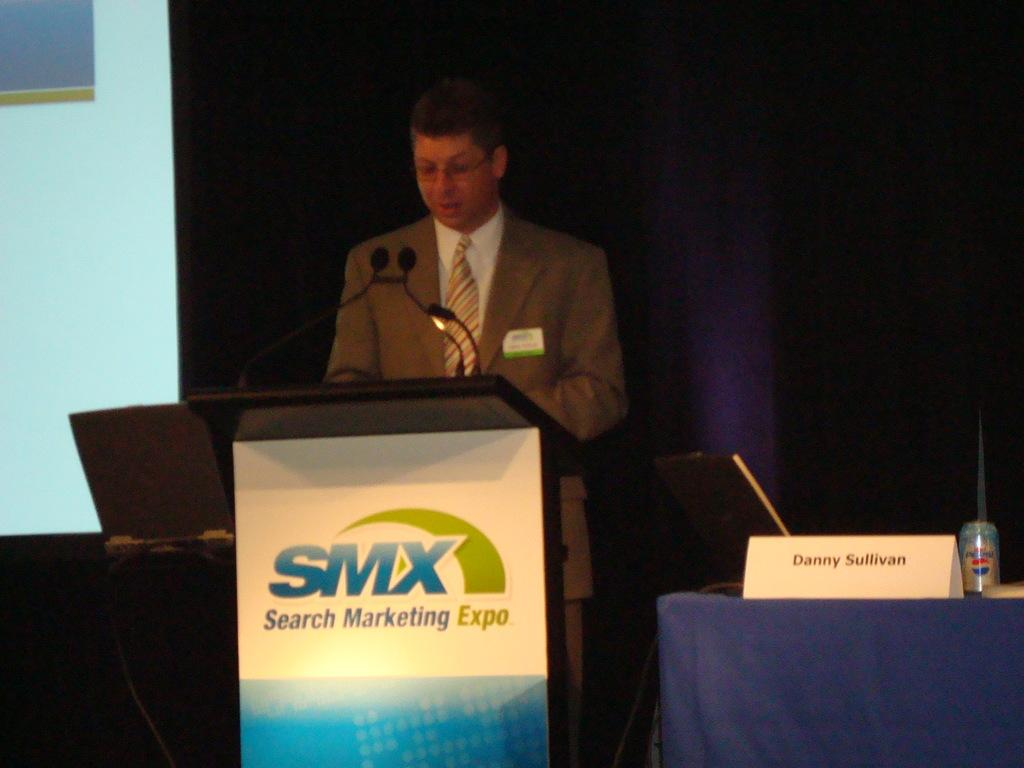<image>
Relay a brief, clear account of the picture shown. A man in a brown suit stands behind a Search Marketing Expo podium. 